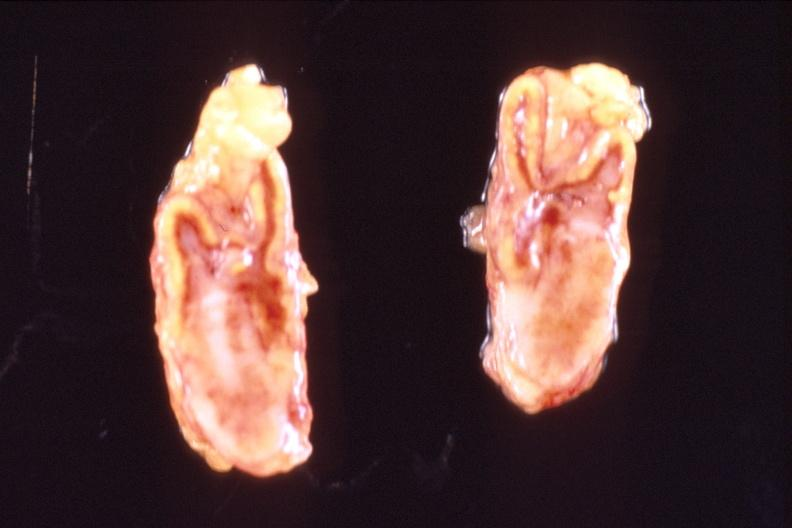does adenoma show adrenal glands, metastatic breast cancer?
Answer the question using a single word or phrase. No 